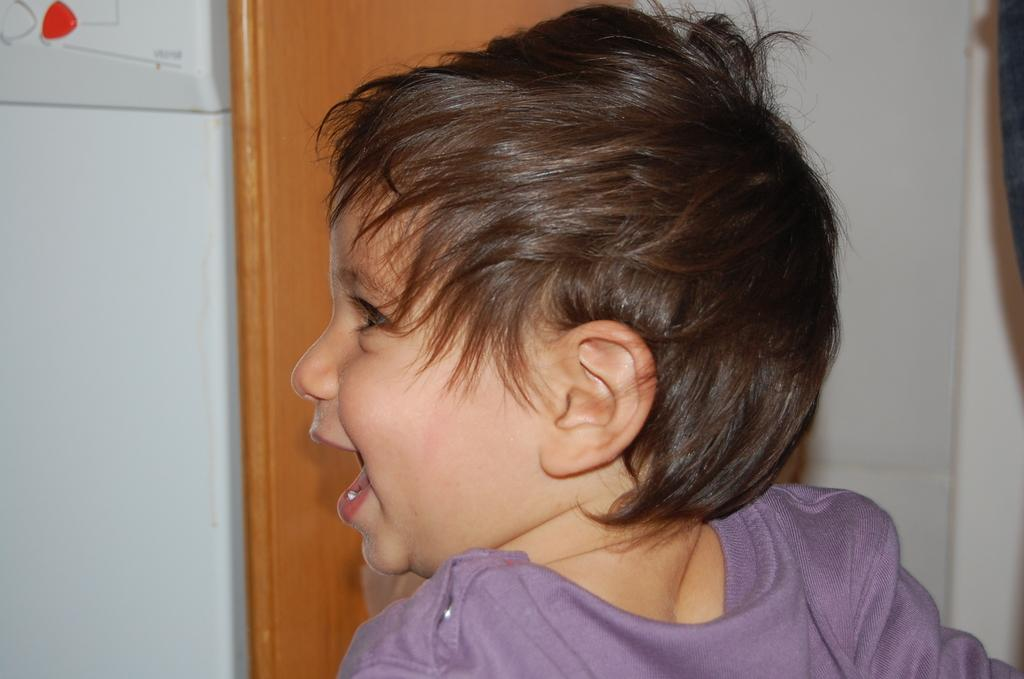What is the main subject of the image? The main subject of the image is a kid. Can you describe the kid's appearance? The kid has black hair and is wearing a blue t-shirt. What can be seen in the background of the image? There is a wooden block and a wall in the background of the image. What type of cave can be seen in the background of the image? There is no cave present in the image; it features a kid with black hair wearing a blue t-shirt, a wooden block, and a wall in the background. 